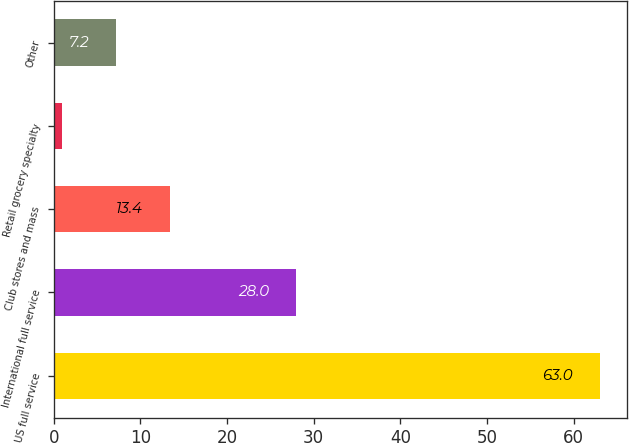Convert chart to OTSL. <chart><loc_0><loc_0><loc_500><loc_500><bar_chart><fcel>US full service<fcel>International full service<fcel>Club stores and mass<fcel>Retail grocery specialty<fcel>Other<nl><fcel>63<fcel>28<fcel>13.4<fcel>1<fcel>7.2<nl></chart> 